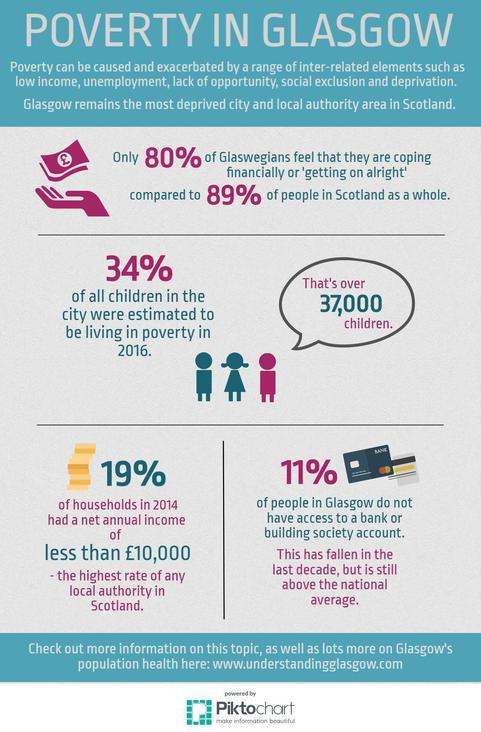Specify some key components in this picture. In the UK, 89% of people have some access to a bank or building society account. In 2016, it was estimated that over 37,000 children in Glasgow were living in poverty. 